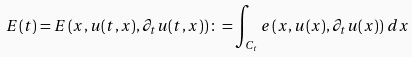Convert formula to latex. <formula><loc_0><loc_0><loc_500><loc_500>E ( t ) = E \left ( x , u ( t , x ) , \partial _ { t } u ( t , x ) \right ) \colon = \int _ { C _ { t } } e \left ( x , u ( x ) , \partial _ { t } u ( x ) \right ) \, d x</formula> 